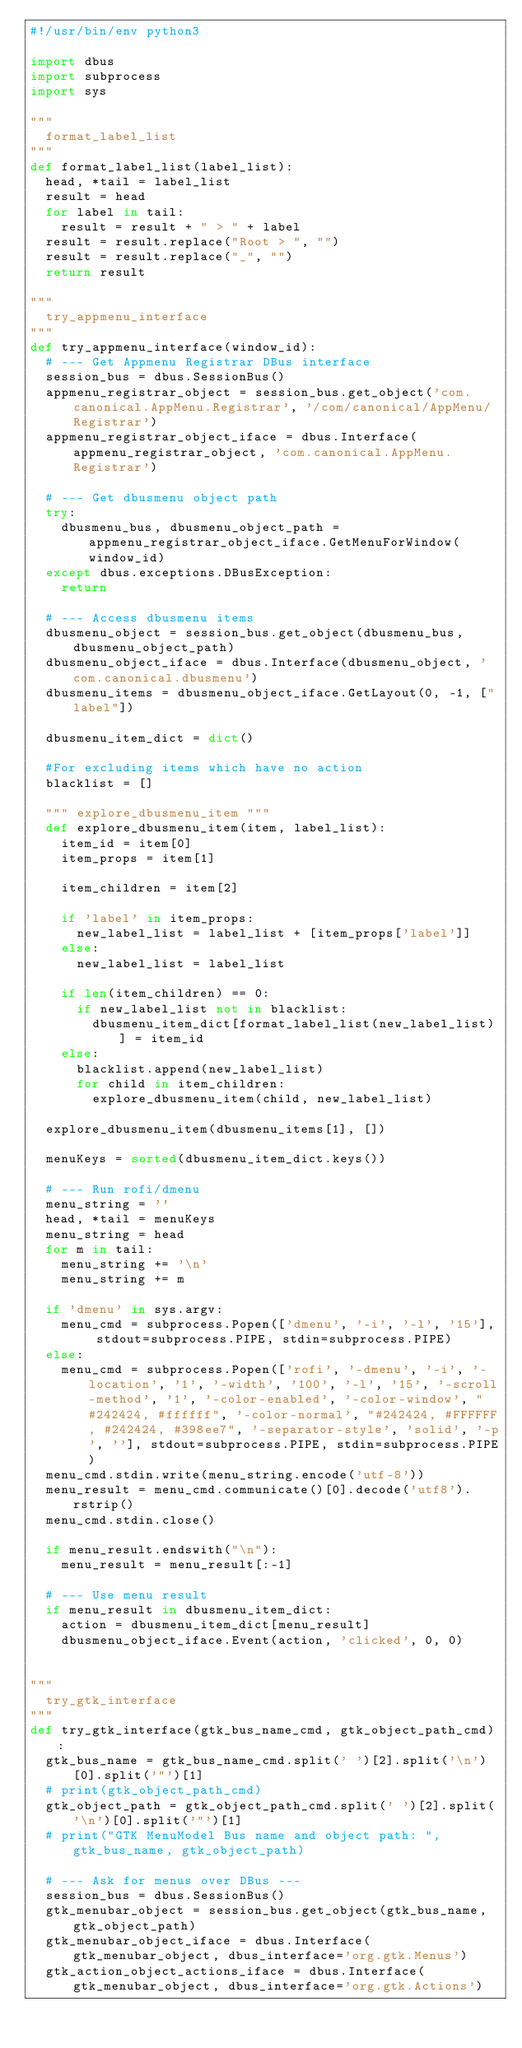<code> <loc_0><loc_0><loc_500><loc_500><_Python_>#!/usr/bin/env python3

import dbus
import subprocess
import sys

"""
  format_label_list
"""
def format_label_list(label_list):
  head, *tail = label_list
  result = head
  for label in tail:
    result = result + " > " + label
  result = result.replace("Root > ", "")
  result = result.replace("_", "")
  return result

"""
  try_appmenu_interface
"""
def try_appmenu_interface(window_id):
  # --- Get Appmenu Registrar DBus interface
  session_bus = dbus.SessionBus()
  appmenu_registrar_object = session_bus.get_object('com.canonical.AppMenu.Registrar', '/com/canonical/AppMenu/Registrar')
  appmenu_registrar_object_iface = dbus.Interface(appmenu_registrar_object, 'com.canonical.AppMenu.Registrar')

  # --- Get dbusmenu object path
  try:
    dbusmenu_bus, dbusmenu_object_path = appmenu_registrar_object_iface.GetMenuForWindow(window_id)
  except dbus.exceptions.DBusException:
    return

  # --- Access dbusmenu items
  dbusmenu_object = session_bus.get_object(dbusmenu_bus, dbusmenu_object_path)
  dbusmenu_object_iface = dbus.Interface(dbusmenu_object, 'com.canonical.dbusmenu')
  dbusmenu_items = dbusmenu_object_iface.GetLayout(0, -1, ["label"])

  dbusmenu_item_dict = dict()

  #For excluding items which have no action
  blacklist = [] 

  """ explore_dbusmenu_item """
  def explore_dbusmenu_item(item, label_list):
    item_id = item[0]
    item_props = item[1]

    item_children = item[2]

    if 'label' in item_props:
      new_label_list = label_list + [item_props['label']]
    else:
      new_label_list = label_list

    if len(item_children) == 0:
      if new_label_list not in blacklist:
        dbusmenu_item_dict[format_label_list(new_label_list)] = item_id
    else:
      blacklist.append(new_label_list)
      for child in item_children:
        explore_dbusmenu_item(child, new_label_list)

  explore_dbusmenu_item(dbusmenu_items[1], [])

  menuKeys = sorted(dbusmenu_item_dict.keys())

  # --- Run rofi/dmenu
  menu_string = ''
  head, *tail = menuKeys
  menu_string = head
  for m in tail:
    menu_string += '\n'
    menu_string += m

  if 'dmenu' in sys.argv:
    menu_cmd = subprocess.Popen(['dmenu', '-i', '-l', '15'], stdout=subprocess.PIPE, stdin=subprocess.PIPE)
  else:
    menu_cmd = subprocess.Popen(['rofi', '-dmenu', '-i', '-location', '1', '-width', '100', '-l', '15', '-scroll-method', '1', '-color-enabled', '-color-window', "#242424, #ffffff", '-color-normal', "#242424, #FFFFFF, #242424, #398ee7", '-separator-style', 'solid', '-p', ''], stdout=subprocess.PIPE, stdin=subprocess.PIPE)
  menu_cmd.stdin.write(menu_string.encode('utf-8'))
  menu_result = menu_cmd.communicate()[0].decode('utf8').rstrip()
  menu_cmd.stdin.close()

  if menu_result.endswith("\n"):
    menu_result = menu_result[:-1]

  # --- Use menu result
  if menu_result in dbusmenu_item_dict:
    action = dbusmenu_item_dict[menu_result]
    dbusmenu_object_iface.Event(action, 'clicked', 0, 0)


"""
  try_gtk_interface
"""
def try_gtk_interface(gtk_bus_name_cmd, gtk_object_path_cmd):
  gtk_bus_name = gtk_bus_name_cmd.split(' ')[2].split('\n')[0].split('"')[1]
  # print(gtk_object_path_cmd)
  gtk_object_path = gtk_object_path_cmd.split(' ')[2].split('\n')[0].split('"')[1]
  # print("GTK MenuModel Bus name and object path: ", gtk_bus_name, gtk_object_path)

  # --- Ask for menus over DBus ---
  session_bus = dbus.SessionBus()
  gtk_menubar_object = session_bus.get_object(gtk_bus_name, gtk_object_path)
  gtk_menubar_object_iface = dbus.Interface(gtk_menubar_object, dbus_interface='org.gtk.Menus')
  gtk_action_object_actions_iface = dbus.Interface(gtk_menubar_object, dbus_interface='org.gtk.Actions')</code> 